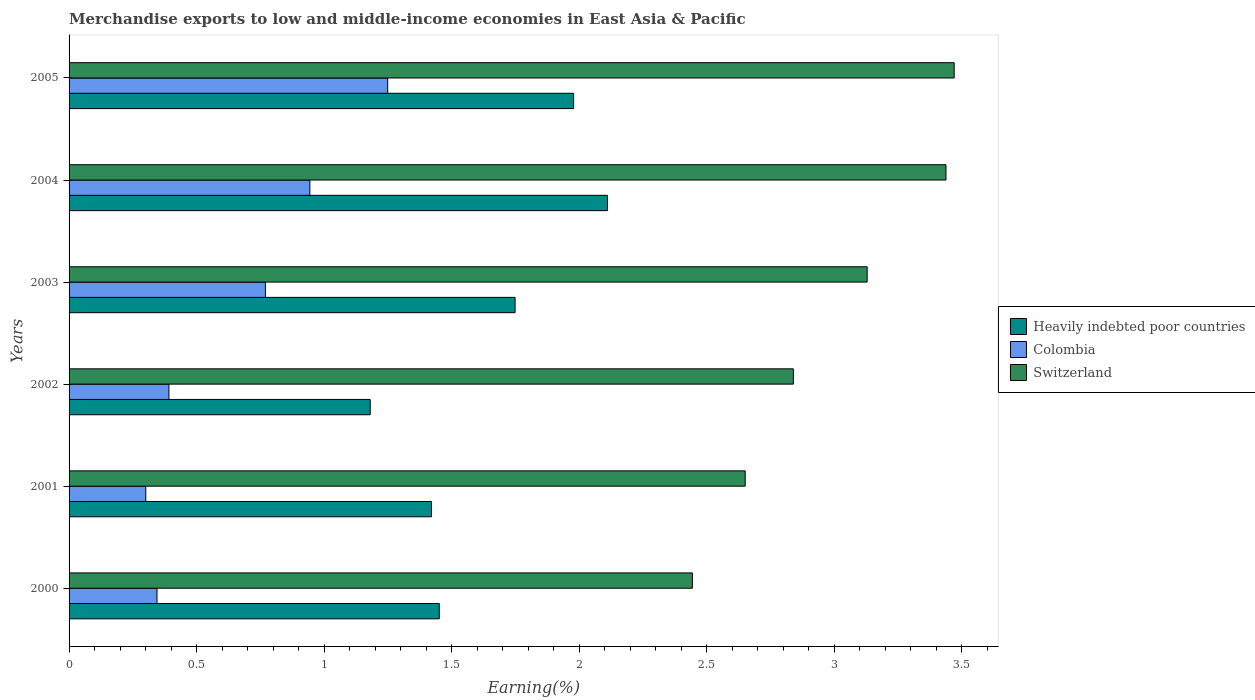Are the number of bars per tick equal to the number of legend labels?
Give a very brief answer. Yes. Are the number of bars on each tick of the Y-axis equal?
Your response must be concise. Yes. How many bars are there on the 6th tick from the top?
Provide a succinct answer. 3. What is the percentage of amount earned from merchandise exports in Colombia in 2001?
Ensure brevity in your answer.  0.3. Across all years, what is the maximum percentage of amount earned from merchandise exports in Heavily indebted poor countries?
Make the answer very short. 2.11. Across all years, what is the minimum percentage of amount earned from merchandise exports in Heavily indebted poor countries?
Offer a terse response. 1.18. In which year was the percentage of amount earned from merchandise exports in Switzerland maximum?
Ensure brevity in your answer.  2005. In which year was the percentage of amount earned from merchandise exports in Switzerland minimum?
Your response must be concise. 2000. What is the total percentage of amount earned from merchandise exports in Colombia in the graph?
Ensure brevity in your answer.  4. What is the difference between the percentage of amount earned from merchandise exports in Heavily indebted poor countries in 2000 and that in 2005?
Make the answer very short. -0.53. What is the difference between the percentage of amount earned from merchandise exports in Heavily indebted poor countries in 2003 and the percentage of amount earned from merchandise exports in Colombia in 2002?
Your response must be concise. 1.36. What is the average percentage of amount earned from merchandise exports in Colombia per year?
Give a very brief answer. 0.67. In the year 2005, what is the difference between the percentage of amount earned from merchandise exports in Heavily indebted poor countries and percentage of amount earned from merchandise exports in Switzerland?
Your response must be concise. -1.49. In how many years, is the percentage of amount earned from merchandise exports in Heavily indebted poor countries greater than 1.5 %?
Give a very brief answer. 3. What is the ratio of the percentage of amount earned from merchandise exports in Heavily indebted poor countries in 2001 to that in 2002?
Offer a very short reply. 1.2. Is the difference between the percentage of amount earned from merchandise exports in Heavily indebted poor countries in 2002 and 2005 greater than the difference between the percentage of amount earned from merchandise exports in Switzerland in 2002 and 2005?
Provide a succinct answer. No. What is the difference between the highest and the second highest percentage of amount earned from merchandise exports in Colombia?
Ensure brevity in your answer.  0.31. What is the difference between the highest and the lowest percentage of amount earned from merchandise exports in Colombia?
Offer a very short reply. 0.95. In how many years, is the percentage of amount earned from merchandise exports in Heavily indebted poor countries greater than the average percentage of amount earned from merchandise exports in Heavily indebted poor countries taken over all years?
Your response must be concise. 3. What does the 1st bar from the top in 2000 represents?
Your answer should be very brief. Switzerland. Is it the case that in every year, the sum of the percentage of amount earned from merchandise exports in Heavily indebted poor countries and percentage of amount earned from merchandise exports in Colombia is greater than the percentage of amount earned from merchandise exports in Switzerland?
Your answer should be very brief. No. How many years are there in the graph?
Provide a short and direct response. 6. Does the graph contain any zero values?
Provide a succinct answer. No. Where does the legend appear in the graph?
Ensure brevity in your answer.  Center right. How many legend labels are there?
Your answer should be compact. 3. How are the legend labels stacked?
Offer a very short reply. Vertical. What is the title of the graph?
Ensure brevity in your answer.  Merchandise exports to low and middle-income economies in East Asia & Pacific. What is the label or title of the X-axis?
Keep it short and to the point. Earning(%). What is the label or title of the Y-axis?
Keep it short and to the point. Years. What is the Earning(%) in Heavily indebted poor countries in 2000?
Provide a succinct answer. 1.45. What is the Earning(%) in Colombia in 2000?
Provide a succinct answer. 0.34. What is the Earning(%) of Switzerland in 2000?
Your answer should be compact. 2.44. What is the Earning(%) of Heavily indebted poor countries in 2001?
Provide a short and direct response. 1.42. What is the Earning(%) of Colombia in 2001?
Your answer should be very brief. 0.3. What is the Earning(%) in Switzerland in 2001?
Keep it short and to the point. 2.65. What is the Earning(%) in Heavily indebted poor countries in 2002?
Your answer should be compact. 1.18. What is the Earning(%) of Colombia in 2002?
Give a very brief answer. 0.39. What is the Earning(%) of Switzerland in 2002?
Keep it short and to the point. 2.84. What is the Earning(%) of Heavily indebted poor countries in 2003?
Provide a short and direct response. 1.75. What is the Earning(%) in Colombia in 2003?
Provide a succinct answer. 0.77. What is the Earning(%) in Switzerland in 2003?
Offer a terse response. 3.13. What is the Earning(%) of Heavily indebted poor countries in 2004?
Offer a very short reply. 2.11. What is the Earning(%) of Colombia in 2004?
Keep it short and to the point. 0.94. What is the Earning(%) of Switzerland in 2004?
Ensure brevity in your answer.  3.44. What is the Earning(%) in Heavily indebted poor countries in 2005?
Your answer should be very brief. 1.98. What is the Earning(%) in Colombia in 2005?
Make the answer very short. 1.25. What is the Earning(%) in Switzerland in 2005?
Make the answer very short. 3.47. Across all years, what is the maximum Earning(%) in Heavily indebted poor countries?
Make the answer very short. 2.11. Across all years, what is the maximum Earning(%) of Colombia?
Your answer should be compact. 1.25. Across all years, what is the maximum Earning(%) in Switzerland?
Offer a terse response. 3.47. Across all years, what is the minimum Earning(%) in Heavily indebted poor countries?
Ensure brevity in your answer.  1.18. Across all years, what is the minimum Earning(%) of Colombia?
Give a very brief answer. 0.3. Across all years, what is the minimum Earning(%) in Switzerland?
Your answer should be compact. 2.44. What is the total Earning(%) in Heavily indebted poor countries in the graph?
Offer a terse response. 9.89. What is the total Earning(%) in Colombia in the graph?
Provide a succinct answer. 4. What is the total Earning(%) of Switzerland in the graph?
Provide a short and direct response. 17.98. What is the difference between the Earning(%) in Heavily indebted poor countries in 2000 and that in 2001?
Your answer should be compact. 0.03. What is the difference between the Earning(%) in Colombia in 2000 and that in 2001?
Your response must be concise. 0.04. What is the difference between the Earning(%) of Switzerland in 2000 and that in 2001?
Give a very brief answer. -0.21. What is the difference between the Earning(%) in Heavily indebted poor countries in 2000 and that in 2002?
Offer a very short reply. 0.27. What is the difference between the Earning(%) in Colombia in 2000 and that in 2002?
Ensure brevity in your answer.  -0.05. What is the difference between the Earning(%) of Switzerland in 2000 and that in 2002?
Offer a very short reply. -0.4. What is the difference between the Earning(%) in Heavily indebted poor countries in 2000 and that in 2003?
Keep it short and to the point. -0.3. What is the difference between the Earning(%) in Colombia in 2000 and that in 2003?
Your answer should be very brief. -0.43. What is the difference between the Earning(%) in Switzerland in 2000 and that in 2003?
Make the answer very short. -0.69. What is the difference between the Earning(%) of Heavily indebted poor countries in 2000 and that in 2004?
Offer a terse response. -0.66. What is the difference between the Earning(%) in Colombia in 2000 and that in 2004?
Give a very brief answer. -0.6. What is the difference between the Earning(%) in Switzerland in 2000 and that in 2004?
Give a very brief answer. -0.99. What is the difference between the Earning(%) of Heavily indebted poor countries in 2000 and that in 2005?
Make the answer very short. -0.53. What is the difference between the Earning(%) in Colombia in 2000 and that in 2005?
Give a very brief answer. -0.9. What is the difference between the Earning(%) in Switzerland in 2000 and that in 2005?
Your answer should be compact. -1.03. What is the difference between the Earning(%) of Heavily indebted poor countries in 2001 and that in 2002?
Ensure brevity in your answer.  0.24. What is the difference between the Earning(%) of Colombia in 2001 and that in 2002?
Provide a succinct answer. -0.09. What is the difference between the Earning(%) of Switzerland in 2001 and that in 2002?
Offer a terse response. -0.19. What is the difference between the Earning(%) in Heavily indebted poor countries in 2001 and that in 2003?
Keep it short and to the point. -0.33. What is the difference between the Earning(%) of Colombia in 2001 and that in 2003?
Provide a succinct answer. -0.47. What is the difference between the Earning(%) of Switzerland in 2001 and that in 2003?
Your answer should be very brief. -0.48. What is the difference between the Earning(%) in Heavily indebted poor countries in 2001 and that in 2004?
Your answer should be very brief. -0.69. What is the difference between the Earning(%) in Colombia in 2001 and that in 2004?
Provide a short and direct response. -0.64. What is the difference between the Earning(%) in Switzerland in 2001 and that in 2004?
Offer a very short reply. -0.79. What is the difference between the Earning(%) in Heavily indebted poor countries in 2001 and that in 2005?
Ensure brevity in your answer.  -0.56. What is the difference between the Earning(%) of Colombia in 2001 and that in 2005?
Provide a succinct answer. -0.95. What is the difference between the Earning(%) in Switzerland in 2001 and that in 2005?
Your answer should be compact. -0.82. What is the difference between the Earning(%) in Heavily indebted poor countries in 2002 and that in 2003?
Your answer should be compact. -0.57. What is the difference between the Earning(%) in Colombia in 2002 and that in 2003?
Keep it short and to the point. -0.38. What is the difference between the Earning(%) in Switzerland in 2002 and that in 2003?
Provide a short and direct response. -0.29. What is the difference between the Earning(%) of Heavily indebted poor countries in 2002 and that in 2004?
Provide a short and direct response. -0.93. What is the difference between the Earning(%) of Colombia in 2002 and that in 2004?
Give a very brief answer. -0.55. What is the difference between the Earning(%) in Switzerland in 2002 and that in 2004?
Provide a succinct answer. -0.6. What is the difference between the Earning(%) in Heavily indebted poor countries in 2002 and that in 2005?
Your response must be concise. -0.8. What is the difference between the Earning(%) in Colombia in 2002 and that in 2005?
Offer a very short reply. -0.86. What is the difference between the Earning(%) of Switzerland in 2002 and that in 2005?
Your answer should be very brief. -0.63. What is the difference between the Earning(%) in Heavily indebted poor countries in 2003 and that in 2004?
Your answer should be very brief. -0.36. What is the difference between the Earning(%) of Colombia in 2003 and that in 2004?
Your response must be concise. -0.17. What is the difference between the Earning(%) of Switzerland in 2003 and that in 2004?
Provide a short and direct response. -0.31. What is the difference between the Earning(%) in Heavily indebted poor countries in 2003 and that in 2005?
Keep it short and to the point. -0.23. What is the difference between the Earning(%) of Colombia in 2003 and that in 2005?
Your answer should be very brief. -0.48. What is the difference between the Earning(%) in Switzerland in 2003 and that in 2005?
Give a very brief answer. -0.34. What is the difference between the Earning(%) of Heavily indebted poor countries in 2004 and that in 2005?
Your response must be concise. 0.13. What is the difference between the Earning(%) in Colombia in 2004 and that in 2005?
Your answer should be compact. -0.31. What is the difference between the Earning(%) in Switzerland in 2004 and that in 2005?
Provide a short and direct response. -0.03. What is the difference between the Earning(%) of Heavily indebted poor countries in 2000 and the Earning(%) of Colombia in 2001?
Make the answer very short. 1.15. What is the difference between the Earning(%) in Heavily indebted poor countries in 2000 and the Earning(%) in Switzerland in 2001?
Keep it short and to the point. -1.2. What is the difference between the Earning(%) in Colombia in 2000 and the Earning(%) in Switzerland in 2001?
Your answer should be compact. -2.31. What is the difference between the Earning(%) in Heavily indebted poor countries in 2000 and the Earning(%) in Colombia in 2002?
Provide a succinct answer. 1.06. What is the difference between the Earning(%) in Heavily indebted poor countries in 2000 and the Earning(%) in Switzerland in 2002?
Offer a terse response. -1.39. What is the difference between the Earning(%) of Colombia in 2000 and the Earning(%) of Switzerland in 2002?
Make the answer very short. -2.5. What is the difference between the Earning(%) of Heavily indebted poor countries in 2000 and the Earning(%) of Colombia in 2003?
Your response must be concise. 0.68. What is the difference between the Earning(%) of Heavily indebted poor countries in 2000 and the Earning(%) of Switzerland in 2003?
Provide a short and direct response. -1.68. What is the difference between the Earning(%) in Colombia in 2000 and the Earning(%) in Switzerland in 2003?
Your response must be concise. -2.78. What is the difference between the Earning(%) in Heavily indebted poor countries in 2000 and the Earning(%) in Colombia in 2004?
Give a very brief answer. 0.51. What is the difference between the Earning(%) of Heavily indebted poor countries in 2000 and the Earning(%) of Switzerland in 2004?
Provide a succinct answer. -1.99. What is the difference between the Earning(%) in Colombia in 2000 and the Earning(%) in Switzerland in 2004?
Your answer should be compact. -3.09. What is the difference between the Earning(%) of Heavily indebted poor countries in 2000 and the Earning(%) of Colombia in 2005?
Offer a very short reply. 0.2. What is the difference between the Earning(%) in Heavily indebted poor countries in 2000 and the Earning(%) in Switzerland in 2005?
Give a very brief answer. -2.02. What is the difference between the Earning(%) of Colombia in 2000 and the Earning(%) of Switzerland in 2005?
Your response must be concise. -3.13. What is the difference between the Earning(%) of Heavily indebted poor countries in 2001 and the Earning(%) of Colombia in 2002?
Keep it short and to the point. 1.03. What is the difference between the Earning(%) of Heavily indebted poor countries in 2001 and the Earning(%) of Switzerland in 2002?
Offer a very short reply. -1.42. What is the difference between the Earning(%) of Colombia in 2001 and the Earning(%) of Switzerland in 2002?
Keep it short and to the point. -2.54. What is the difference between the Earning(%) in Heavily indebted poor countries in 2001 and the Earning(%) in Colombia in 2003?
Offer a terse response. 0.65. What is the difference between the Earning(%) of Heavily indebted poor countries in 2001 and the Earning(%) of Switzerland in 2003?
Keep it short and to the point. -1.71. What is the difference between the Earning(%) in Colombia in 2001 and the Earning(%) in Switzerland in 2003?
Your response must be concise. -2.83. What is the difference between the Earning(%) in Heavily indebted poor countries in 2001 and the Earning(%) in Colombia in 2004?
Ensure brevity in your answer.  0.48. What is the difference between the Earning(%) of Heavily indebted poor countries in 2001 and the Earning(%) of Switzerland in 2004?
Your answer should be compact. -2.02. What is the difference between the Earning(%) in Colombia in 2001 and the Earning(%) in Switzerland in 2004?
Offer a terse response. -3.14. What is the difference between the Earning(%) in Heavily indebted poor countries in 2001 and the Earning(%) in Colombia in 2005?
Your response must be concise. 0.17. What is the difference between the Earning(%) of Heavily indebted poor countries in 2001 and the Earning(%) of Switzerland in 2005?
Ensure brevity in your answer.  -2.05. What is the difference between the Earning(%) of Colombia in 2001 and the Earning(%) of Switzerland in 2005?
Your response must be concise. -3.17. What is the difference between the Earning(%) of Heavily indebted poor countries in 2002 and the Earning(%) of Colombia in 2003?
Offer a very short reply. 0.41. What is the difference between the Earning(%) of Heavily indebted poor countries in 2002 and the Earning(%) of Switzerland in 2003?
Offer a very short reply. -1.95. What is the difference between the Earning(%) of Colombia in 2002 and the Earning(%) of Switzerland in 2003?
Your response must be concise. -2.74. What is the difference between the Earning(%) in Heavily indebted poor countries in 2002 and the Earning(%) in Colombia in 2004?
Provide a short and direct response. 0.24. What is the difference between the Earning(%) in Heavily indebted poor countries in 2002 and the Earning(%) in Switzerland in 2004?
Ensure brevity in your answer.  -2.26. What is the difference between the Earning(%) in Colombia in 2002 and the Earning(%) in Switzerland in 2004?
Ensure brevity in your answer.  -3.05. What is the difference between the Earning(%) of Heavily indebted poor countries in 2002 and the Earning(%) of Colombia in 2005?
Your answer should be compact. -0.07. What is the difference between the Earning(%) in Heavily indebted poor countries in 2002 and the Earning(%) in Switzerland in 2005?
Offer a very short reply. -2.29. What is the difference between the Earning(%) of Colombia in 2002 and the Earning(%) of Switzerland in 2005?
Keep it short and to the point. -3.08. What is the difference between the Earning(%) of Heavily indebted poor countries in 2003 and the Earning(%) of Colombia in 2004?
Your answer should be compact. 0.8. What is the difference between the Earning(%) of Heavily indebted poor countries in 2003 and the Earning(%) of Switzerland in 2004?
Your answer should be very brief. -1.69. What is the difference between the Earning(%) of Colombia in 2003 and the Earning(%) of Switzerland in 2004?
Your answer should be compact. -2.67. What is the difference between the Earning(%) in Heavily indebted poor countries in 2003 and the Earning(%) in Colombia in 2005?
Make the answer very short. 0.5. What is the difference between the Earning(%) of Heavily indebted poor countries in 2003 and the Earning(%) of Switzerland in 2005?
Provide a short and direct response. -1.72. What is the difference between the Earning(%) in Colombia in 2003 and the Earning(%) in Switzerland in 2005?
Provide a succinct answer. -2.7. What is the difference between the Earning(%) in Heavily indebted poor countries in 2004 and the Earning(%) in Colombia in 2005?
Provide a succinct answer. 0.86. What is the difference between the Earning(%) in Heavily indebted poor countries in 2004 and the Earning(%) in Switzerland in 2005?
Your answer should be very brief. -1.36. What is the difference between the Earning(%) in Colombia in 2004 and the Earning(%) in Switzerland in 2005?
Give a very brief answer. -2.53. What is the average Earning(%) in Heavily indebted poor countries per year?
Keep it short and to the point. 1.65. What is the average Earning(%) of Colombia per year?
Offer a terse response. 0.67. What is the average Earning(%) in Switzerland per year?
Make the answer very short. 3. In the year 2000, what is the difference between the Earning(%) of Heavily indebted poor countries and Earning(%) of Colombia?
Offer a very short reply. 1.11. In the year 2000, what is the difference between the Earning(%) in Heavily indebted poor countries and Earning(%) in Switzerland?
Give a very brief answer. -0.99. In the year 2000, what is the difference between the Earning(%) in Colombia and Earning(%) in Switzerland?
Your answer should be compact. -2.1. In the year 2001, what is the difference between the Earning(%) of Heavily indebted poor countries and Earning(%) of Colombia?
Give a very brief answer. 1.12. In the year 2001, what is the difference between the Earning(%) in Heavily indebted poor countries and Earning(%) in Switzerland?
Ensure brevity in your answer.  -1.23. In the year 2001, what is the difference between the Earning(%) of Colombia and Earning(%) of Switzerland?
Give a very brief answer. -2.35. In the year 2002, what is the difference between the Earning(%) in Heavily indebted poor countries and Earning(%) in Colombia?
Offer a very short reply. 0.79. In the year 2002, what is the difference between the Earning(%) of Heavily indebted poor countries and Earning(%) of Switzerland?
Your answer should be compact. -1.66. In the year 2002, what is the difference between the Earning(%) of Colombia and Earning(%) of Switzerland?
Make the answer very short. -2.45. In the year 2003, what is the difference between the Earning(%) of Heavily indebted poor countries and Earning(%) of Colombia?
Provide a short and direct response. 0.98. In the year 2003, what is the difference between the Earning(%) of Heavily indebted poor countries and Earning(%) of Switzerland?
Your response must be concise. -1.38. In the year 2003, what is the difference between the Earning(%) of Colombia and Earning(%) of Switzerland?
Offer a terse response. -2.36. In the year 2004, what is the difference between the Earning(%) of Heavily indebted poor countries and Earning(%) of Colombia?
Your answer should be very brief. 1.17. In the year 2004, what is the difference between the Earning(%) in Heavily indebted poor countries and Earning(%) in Switzerland?
Your response must be concise. -1.33. In the year 2004, what is the difference between the Earning(%) of Colombia and Earning(%) of Switzerland?
Provide a succinct answer. -2.49. In the year 2005, what is the difference between the Earning(%) of Heavily indebted poor countries and Earning(%) of Colombia?
Your answer should be very brief. 0.73. In the year 2005, what is the difference between the Earning(%) in Heavily indebted poor countries and Earning(%) in Switzerland?
Keep it short and to the point. -1.49. In the year 2005, what is the difference between the Earning(%) of Colombia and Earning(%) of Switzerland?
Your response must be concise. -2.22. What is the ratio of the Earning(%) of Heavily indebted poor countries in 2000 to that in 2001?
Provide a succinct answer. 1.02. What is the ratio of the Earning(%) in Colombia in 2000 to that in 2001?
Provide a succinct answer. 1.15. What is the ratio of the Earning(%) of Switzerland in 2000 to that in 2001?
Offer a very short reply. 0.92. What is the ratio of the Earning(%) in Heavily indebted poor countries in 2000 to that in 2002?
Give a very brief answer. 1.23. What is the ratio of the Earning(%) of Colombia in 2000 to that in 2002?
Give a very brief answer. 0.88. What is the ratio of the Earning(%) in Switzerland in 2000 to that in 2002?
Give a very brief answer. 0.86. What is the ratio of the Earning(%) in Heavily indebted poor countries in 2000 to that in 2003?
Make the answer very short. 0.83. What is the ratio of the Earning(%) of Colombia in 2000 to that in 2003?
Your answer should be very brief. 0.45. What is the ratio of the Earning(%) in Switzerland in 2000 to that in 2003?
Provide a succinct answer. 0.78. What is the ratio of the Earning(%) in Heavily indebted poor countries in 2000 to that in 2004?
Keep it short and to the point. 0.69. What is the ratio of the Earning(%) of Colombia in 2000 to that in 2004?
Your response must be concise. 0.37. What is the ratio of the Earning(%) of Switzerland in 2000 to that in 2004?
Your response must be concise. 0.71. What is the ratio of the Earning(%) of Heavily indebted poor countries in 2000 to that in 2005?
Give a very brief answer. 0.73. What is the ratio of the Earning(%) in Colombia in 2000 to that in 2005?
Give a very brief answer. 0.28. What is the ratio of the Earning(%) of Switzerland in 2000 to that in 2005?
Your response must be concise. 0.7. What is the ratio of the Earning(%) in Heavily indebted poor countries in 2001 to that in 2002?
Make the answer very short. 1.2. What is the ratio of the Earning(%) of Colombia in 2001 to that in 2002?
Your response must be concise. 0.77. What is the ratio of the Earning(%) of Switzerland in 2001 to that in 2002?
Ensure brevity in your answer.  0.93. What is the ratio of the Earning(%) in Heavily indebted poor countries in 2001 to that in 2003?
Make the answer very short. 0.81. What is the ratio of the Earning(%) of Colombia in 2001 to that in 2003?
Your answer should be very brief. 0.39. What is the ratio of the Earning(%) in Switzerland in 2001 to that in 2003?
Make the answer very short. 0.85. What is the ratio of the Earning(%) of Heavily indebted poor countries in 2001 to that in 2004?
Offer a terse response. 0.67. What is the ratio of the Earning(%) in Colombia in 2001 to that in 2004?
Offer a very short reply. 0.32. What is the ratio of the Earning(%) in Switzerland in 2001 to that in 2004?
Your answer should be compact. 0.77. What is the ratio of the Earning(%) in Heavily indebted poor countries in 2001 to that in 2005?
Give a very brief answer. 0.72. What is the ratio of the Earning(%) of Colombia in 2001 to that in 2005?
Your answer should be very brief. 0.24. What is the ratio of the Earning(%) of Switzerland in 2001 to that in 2005?
Make the answer very short. 0.76. What is the ratio of the Earning(%) of Heavily indebted poor countries in 2002 to that in 2003?
Provide a short and direct response. 0.68. What is the ratio of the Earning(%) in Colombia in 2002 to that in 2003?
Provide a short and direct response. 0.51. What is the ratio of the Earning(%) of Switzerland in 2002 to that in 2003?
Ensure brevity in your answer.  0.91. What is the ratio of the Earning(%) of Heavily indebted poor countries in 2002 to that in 2004?
Offer a very short reply. 0.56. What is the ratio of the Earning(%) in Colombia in 2002 to that in 2004?
Offer a very short reply. 0.41. What is the ratio of the Earning(%) in Switzerland in 2002 to that in 2004?
Your answer should be compact. 0.83. What is the ratio of the Earning(%) of Heavily indebted poor countries in 2002 to that in 2005?
Keep it short and to the point. 0.6. What is the ratio of the Earning(%) of Colombia in 2002 to that in 2005?
Provide a short and direct response. 0.31. What is the ratio of the Earning(%) in Switzerland in 2002 to that in 2005?
Provide a succinct answer. 0.82. What is the ratio of the Earning(%) in Heavily indebted poor countries in 2003 to that in 2004?
Ensure brevity in your answer.  0.83. What is the ratio of the Earning(%) in Colombia in 2003 to that in 2004?
Give a very brief answer. 0.82. What is the ratio of the Earning(%) in Switzerland in 2003 to that in 2004?
Provide a short and direct response. 0.91. What is the ratio of the Earning(%) of Heavily indebted poor countries in 2003 to that in 2005?
Give a very brief answer. 0.88. What is the ratio of the Earning(%) in Colombia in 2003 to that in 2005?
Keep it short and to the point. 0.62. What is the ratio of the Earning(%) of Switzerland in 2003 to that in 2005?
Keep it short and to the point. 0.9. What is the ratio of the Earning(%) of Heavily indebted poor countries in 2004 to that in 2005?
Provide a short and direct response. 1.07. What is the ratio of the Earning(%) in Colombia in 2004 to that in 2005?
Your response must be concise. 0.76. What is the difference between the highest and the second highest Earning(%) in Heavily indebted poor countries?
Ensure brevity in your answer.  0.13. What is the difference between the highest and the second highest Earning(%) in Colombia?
Offer a terse response. 0.31. What is the difference between the highest and the second highest Earning(%) in Switzerland?
Make the answer very short. 0.03. What is the difference between the highest and the lowest Earning(%) in Heavily indebted poor countries?
Give a very brief answer. 0.93. What is the difference between the highest and the lowest Earning(%) in Colombia?
Make the answer very short. 0.95. What is the difference between the highest and the lowest Earning(%) of Switzerland?
Keep it short and to the point. 1.03. 